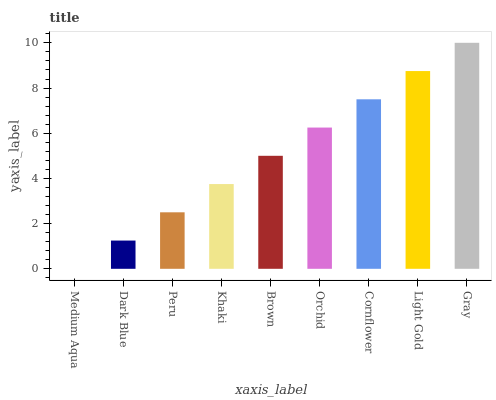Is Medium Aqua the minimum?
Answer yes or no. Yes. Is Gray the maximum?
Answer yes or no. Yes. Is Dark Blue the minimum?
Answer yes or no. No. Is Dark Blue the maximum?
Answer yes or no. No. Is Dark Blue greater than Medium Aqua?
Answer yes or no. Yes. Is Medium Aqua less than Dark Blue?
Answer yes or no. Yes. Is Medium Aqua greater than Dark Blue?
Answer yes or no. No. Is Dark Blue less than Medium Aqua?
Answer yes or no. No. Is Brown the high median?
Answer yes or no. Yes. Is Brown the low median?
Answer yes or no. Yes. Is Medium Aqua the high median?
Answer yes or no. No. Is Gray the low median?
Answer yes or no. No. 